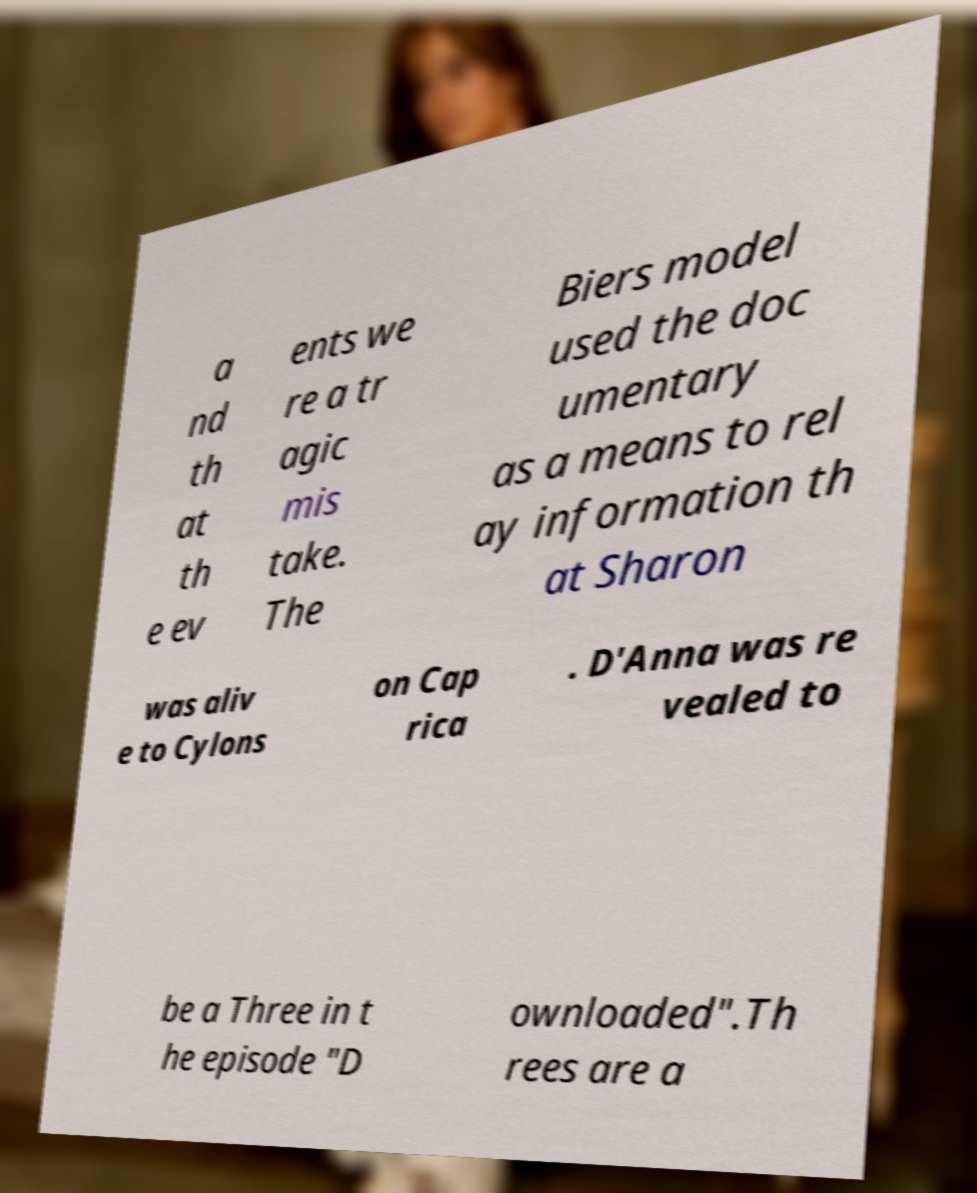For documentation purposes, I need the text within this image transcribed. Could you provide that? a nd th at th e ev ents we re a tr agic mis take. The Biers model used the doc umentary as a means to rel ay information th at Sharon was aliv e to Cylons on Cap rica . D'Anna was re vealed to be a Three in t he episode "D ownloaded".Th rees are a 